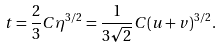<formula> <loc_0><loc_0><loc_500><loc_500>t = \frac { 2 } { 3 } C \eta ^ { 3 / 2 } = \frac { 1 } { 3 \sqrt { 2 } } C ( u + v ) ^ { 3 / 2 } .</formula> 